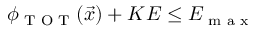Convert formula to latex. <formula><loc_0><loc_0><loc_500><loc_500>\phi _ { T O T } ( \vec { x } ) + K E \leq E _ { \max }</formula> 